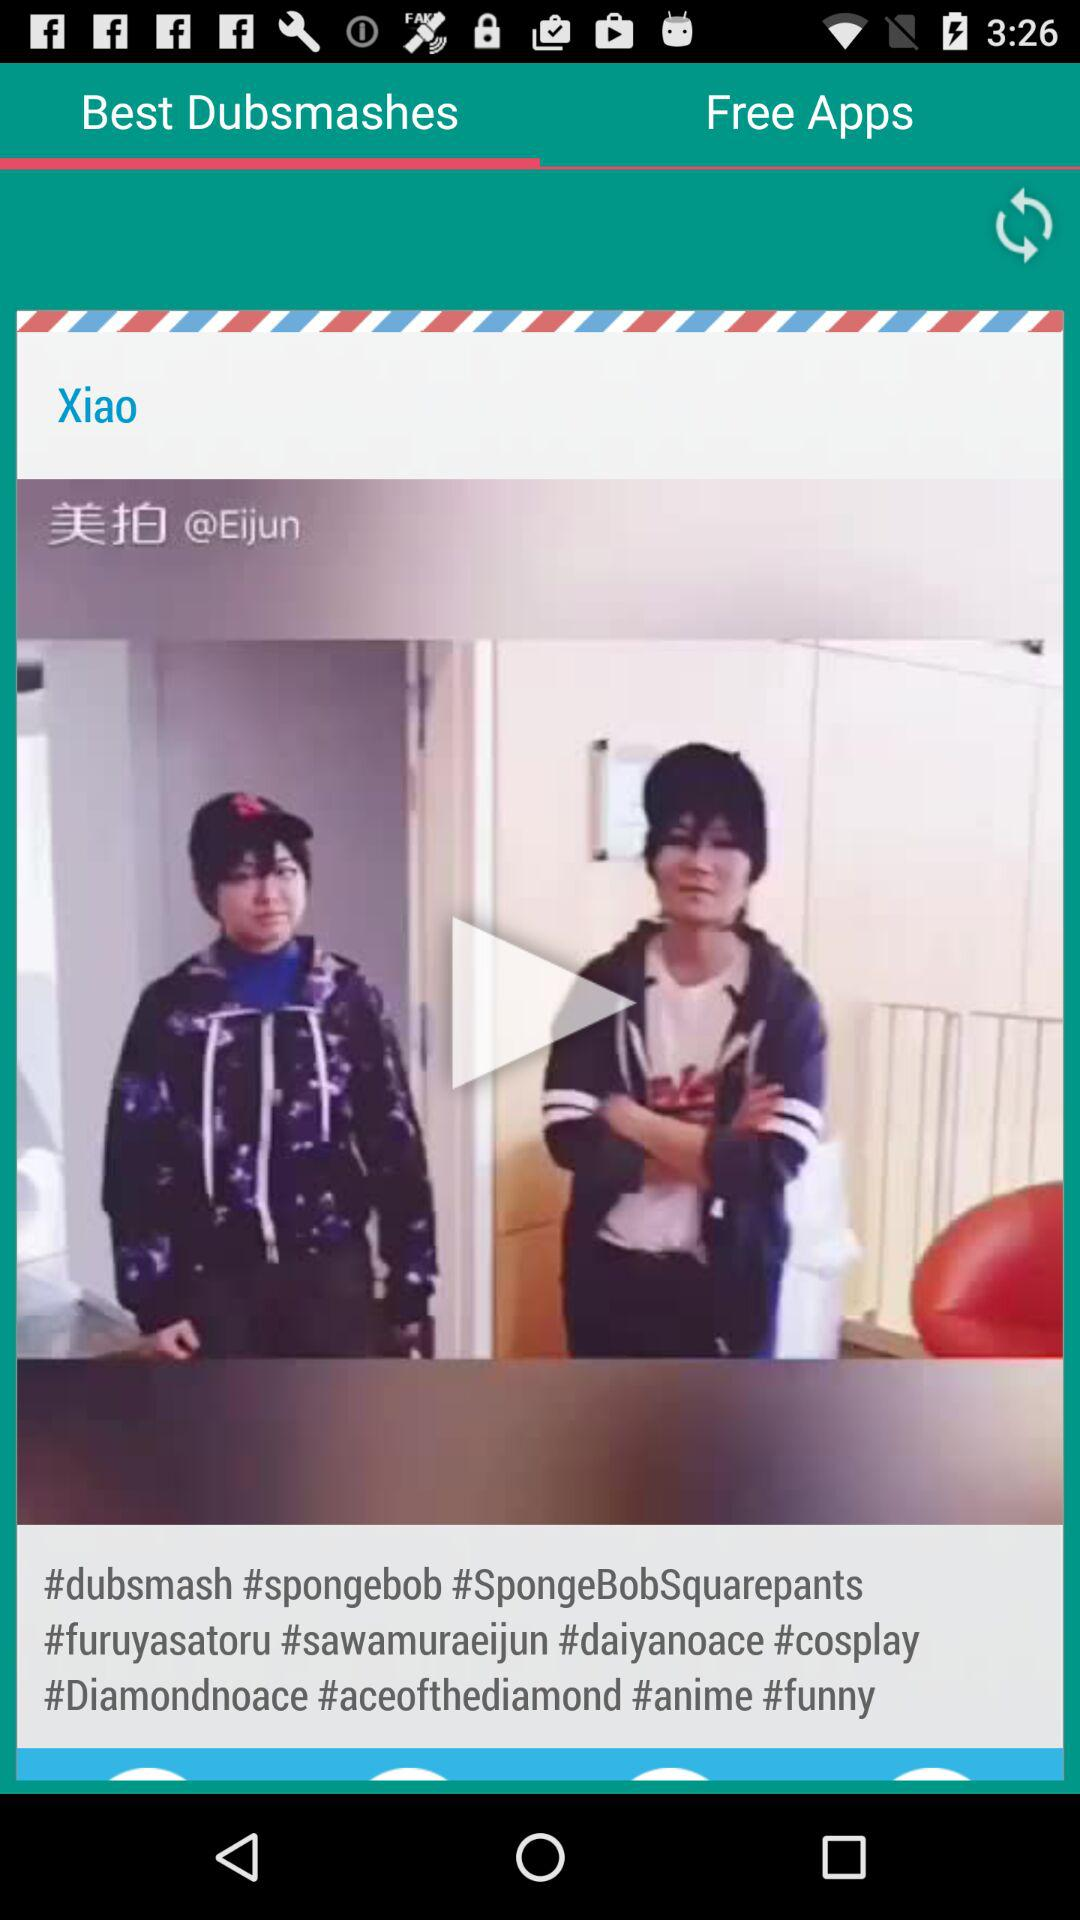Which tab is selected? The selected tab is "Best Dubsmashes". 